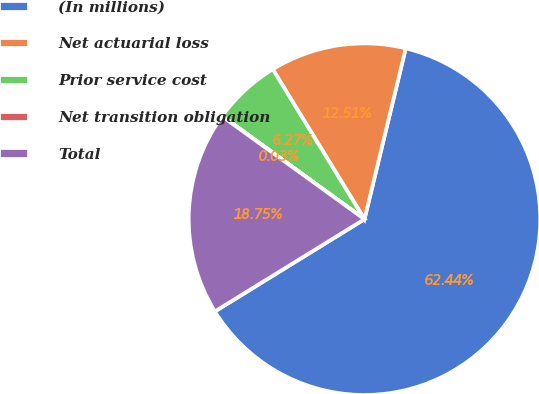Convert chart to OTSL. <chart><loc_0><loc_0><loc_500><loc_500><pie_chart><fcel>(In millions)<fcel>Net actuarial loss<fcel>Prior service cost<fcel>Net transition obligation<fcel>Total<nl><fcel>62.43%<fcel>12.51%<fcel>6.27%<fcel>0.03%<fcel>18.75%<nl></chart> 